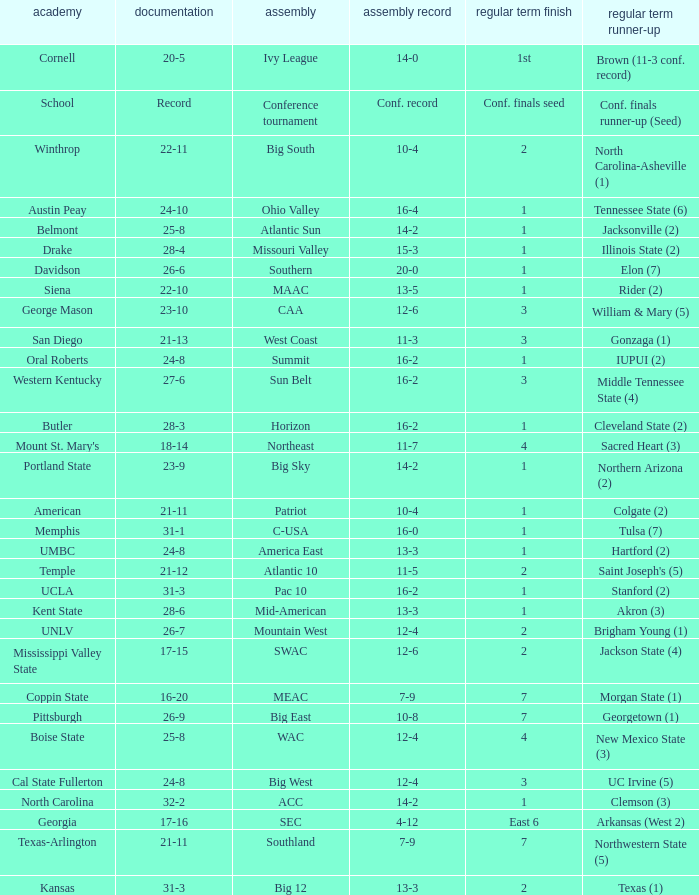Which conference is Belmont in? Atlantic Sun. 